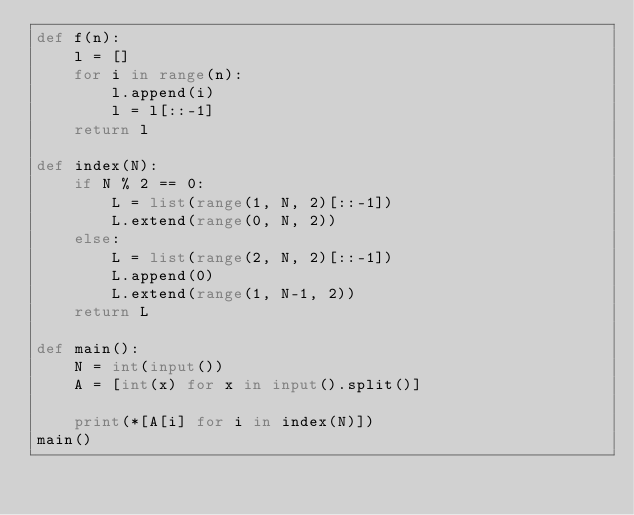Convert code to text. <code><loc_0><loc_0><loc_500><loc_500><_Python_>def f(n):
    l = []
    for i in range(n):
        l.append(i)
        l = l[::-1]
    return l

def index(N):
    if N % 2 == 0:
        L = list(range(1, N, 2)[::-1])
        L.extend(range(0, N, 2))
    else:
        L = list(range(2, N, 2)[::-1])
        L.append(0)
        L.extend(range(1, N-1, 2))
    return L

def main():
    N = int(input())
    A = [int(x) for x in input().split()]

    print(*[A[i] for i in index(N)])
main()
</code> 